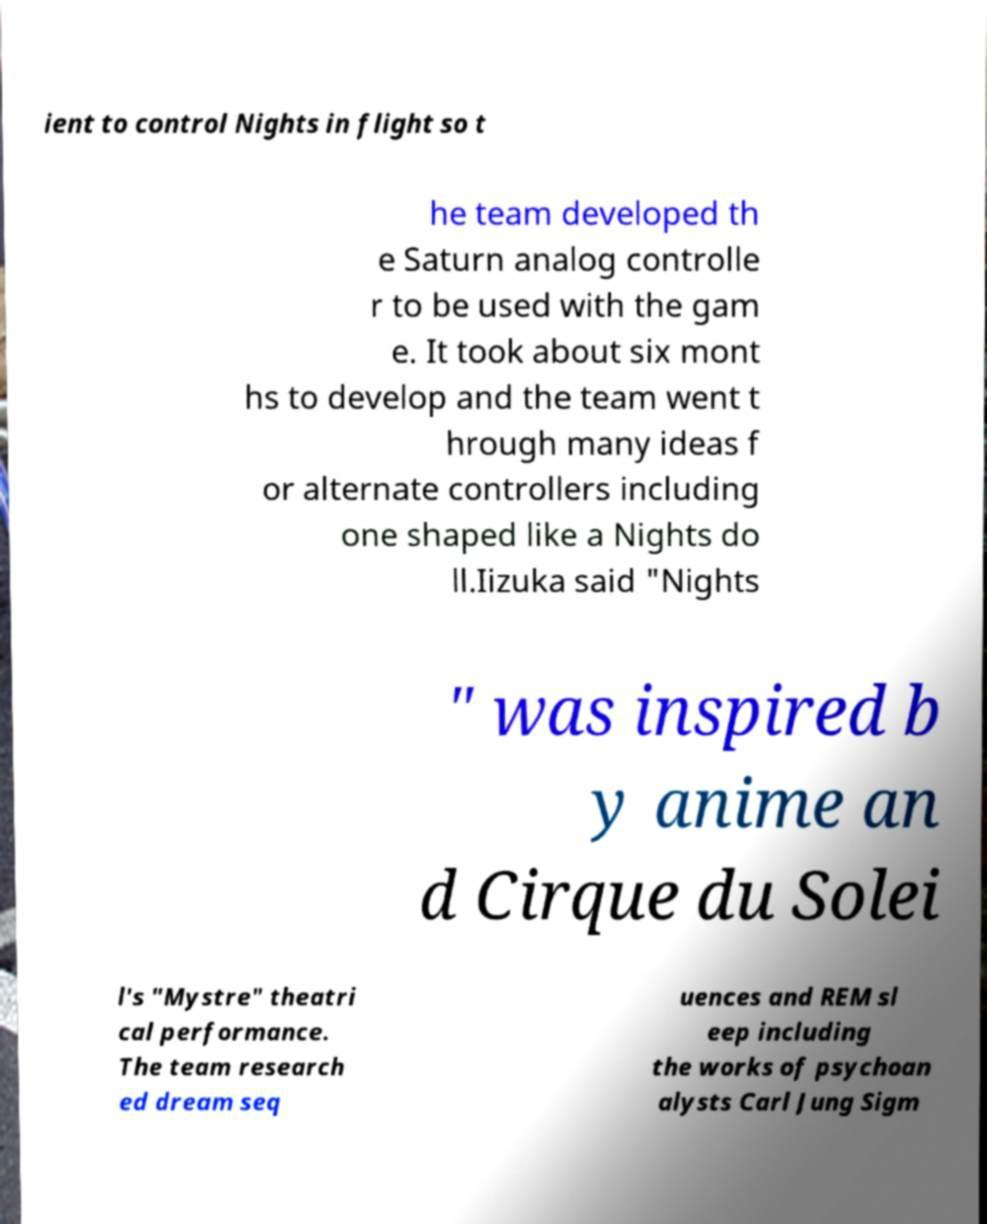There's text embedded in this image that I need extracted. Can you transcribe it verbatim? ient to control Nights in flight so t he team developed th e Saturn analog controlle r to be used with the gam e. It took about six mont hs to develop and the team went t hrough many ideas f or alternate controllers including one shaped like a Nights do ll.Iizuka said "Nights " was inspired b y anime an d Cirque du Solei l's "Mystre" theatri cal performance. The team research ed dream seq uences and REM sl eep including the works of psychoan alysts Carl Jung Sigm 